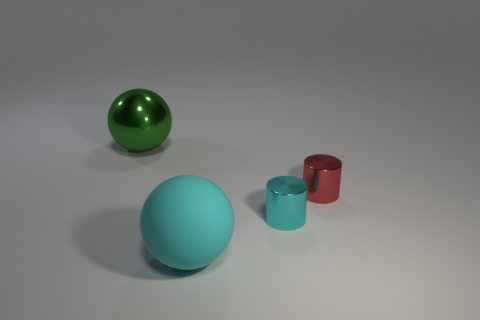Add 4 purple matte cylinders. How many objects exist? 8 Subtract all red cylinders. How many cylinders are left? 1 Subtract 2 balls. How many balls are left? 0 Subtract all brown balls. Subtract all green blocks. How many balls are left? 2 Subtract all blue balls. How many red cylinders are left? 1 Add 4 tiny shiny cylinders. How many tiny shiny cylinders are left? 6 Add 2 red things. How many red things exist? 3 Subtract 1 cyan balls. How many objects are left? 3 Subtract all gray metallic balls. Subtract all large matte objects. How many objects are left? 3 